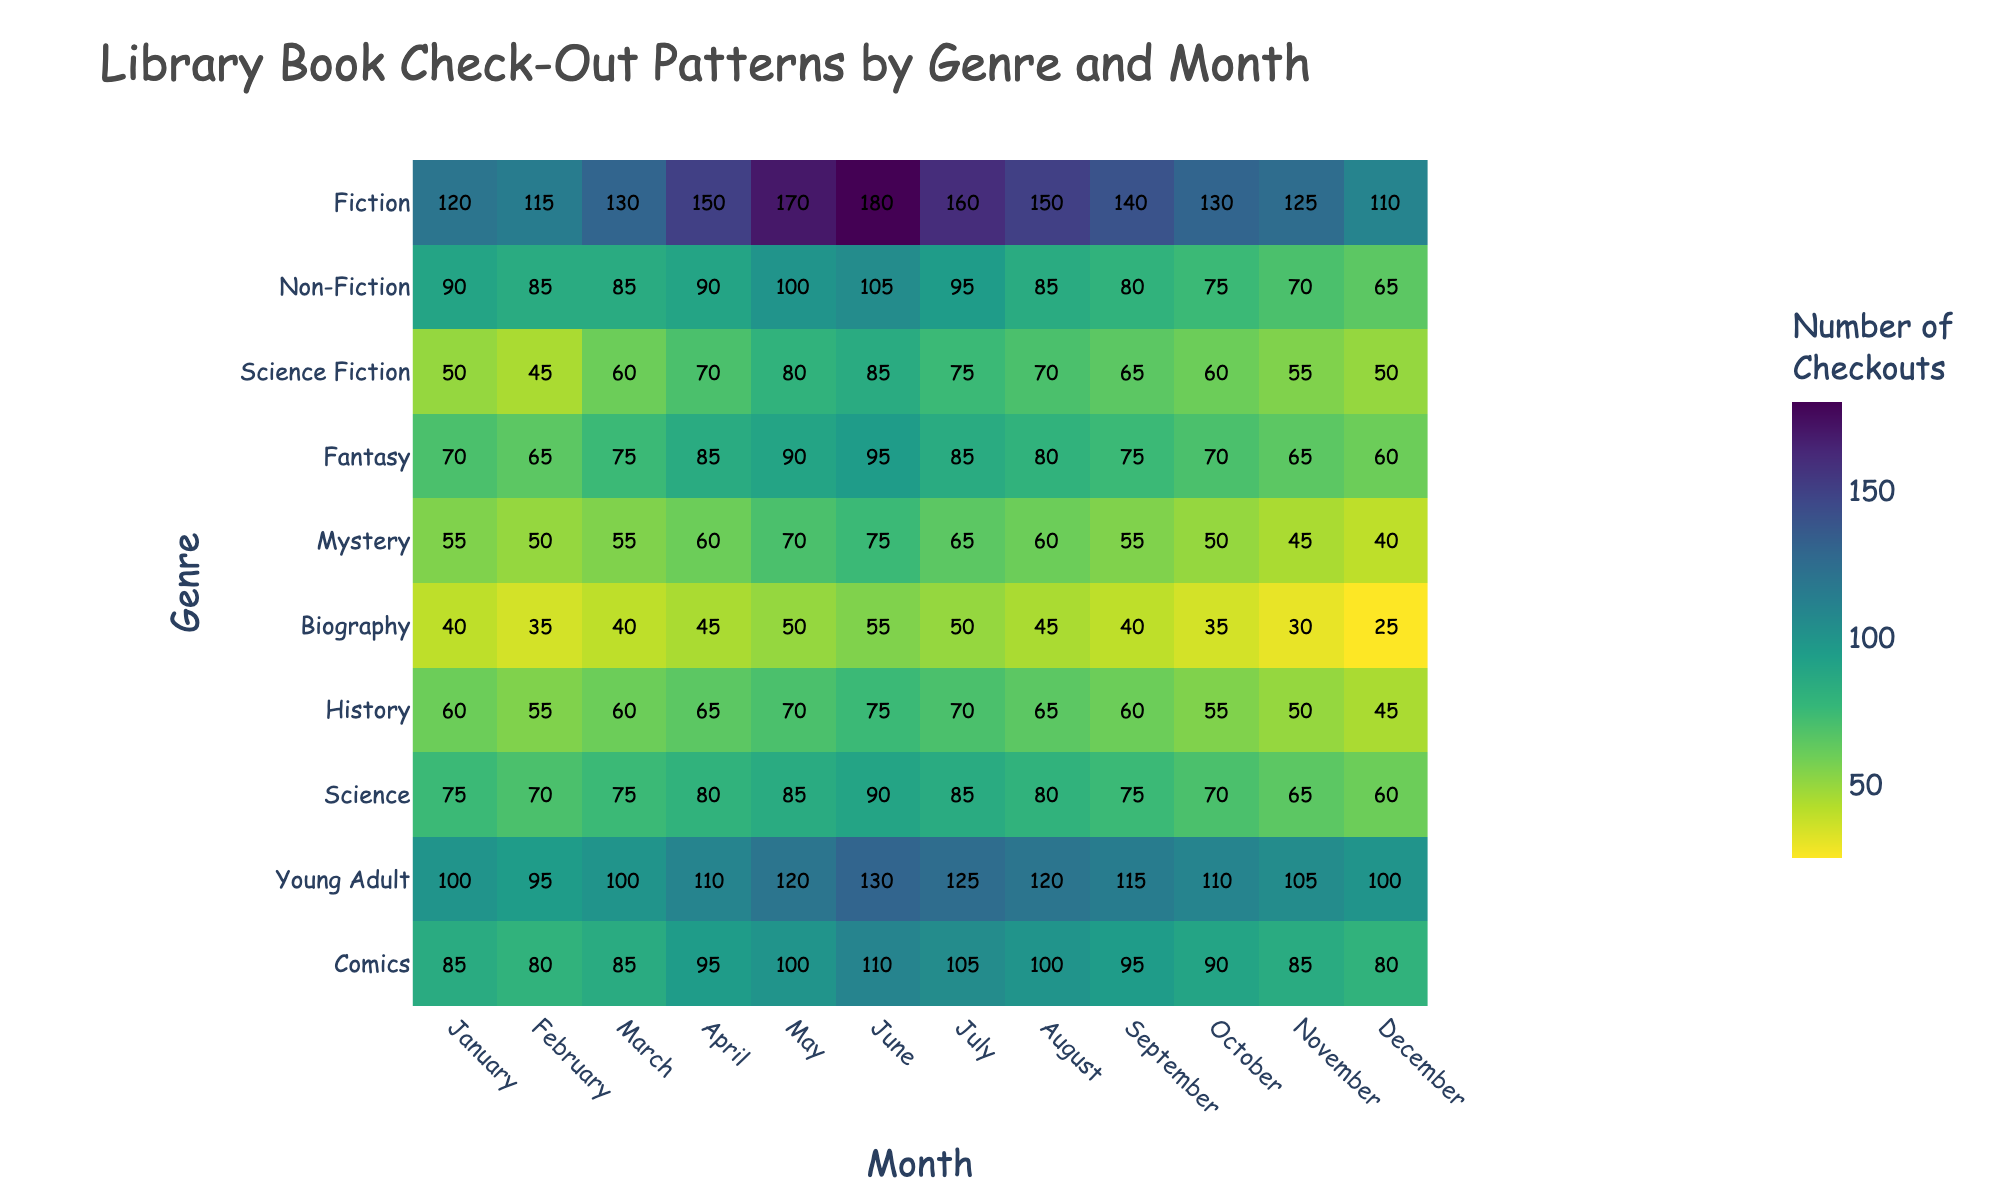Which month had the highest number of checkouts for Fiction? Look for the month with the highest number (180) in the row corresponding to Fiction. June shows the highest value.
Answer: June Which genre had the lowest number of checkouts in December? Find the smallest number in the December column. 25 is the smallest and corresponds to Biography.
Answer: Biography How many checkouts were recorded for Non-Fiction from May to August? Sum up the checkouts for Non-Fiction from May to August: 100 + 105 + 95 + 85 = 385.
Answer: 385 Which genre had more checkouts in March, Science Fiction or Mystery? Compare the March values for Science Fiction (60) and Mystery (55). Science Fiction has higher checkouts.
Answer: Science Fiction What’s the difference in checkouts between January and December for Young Adult? Calculate the difference between January (100) and December (100) checkouts for Young Adult. 100 - 100 = 0.
Answer: 0 How did the checkouts for Fantasy change from February to November? Track the change in checkouts for Fantasy from February (65) to November (65). The number decreased then increased, ending at 65 in November.
Answer: Decrease first, then increase back to 65 Which genre shows the most consistent check-out patterns throughout the year? Look for the genre with the least variability in numbers across months. Non-Fiction ranges from 65 to 105, showing relatively consistent checkouts.
Answer: Non-Fiction In which month did History genre checkouts peak? Find the highest number in the History row. The peak (75) is in June.
Answer: June What is the total number of checkouts for Comics in the first half of the year (January to June)? Sum the checkouts for Comics from January to June: 85 + 80 + 85 + 95 + 100 + 110 = 555.
Answer: 555 